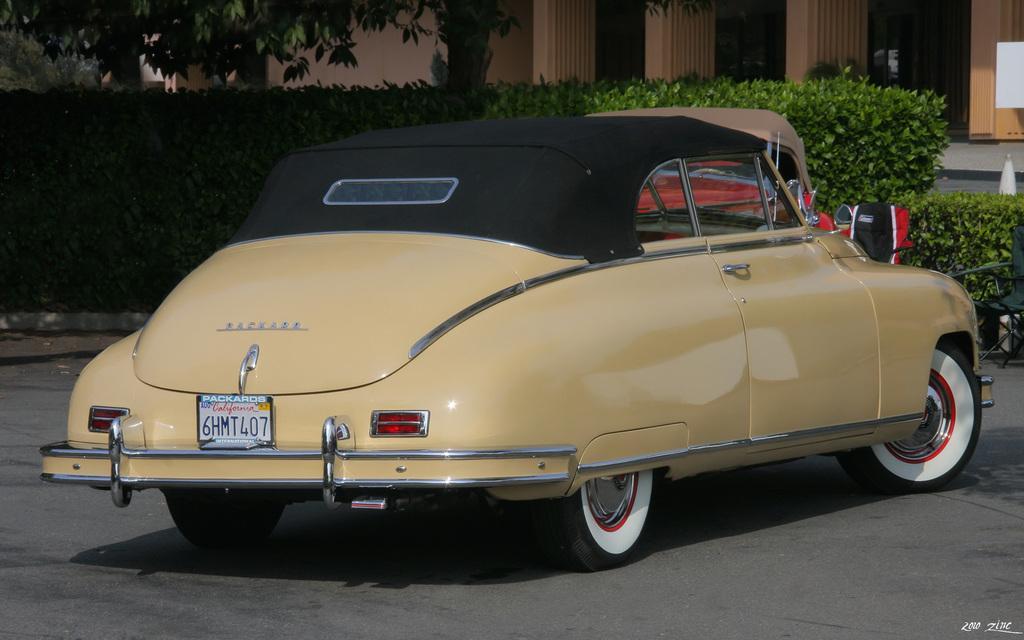Please provide a concise description of this image. In this picture I can observe a car on the road. This car is in yellow color. In the background there are plants, trees and a building. 